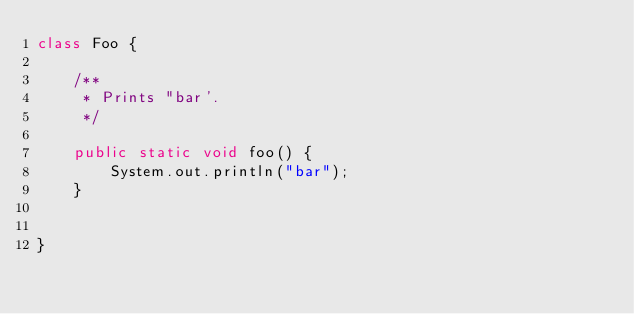Convert code to text. <code><loc_0><loc_0><loc_500><loc_500><_Java_>class Foo {

    /**
     * Prints "bar'.
     */

    public static void foo() {
        System.out.println("bar");
    }


}

</code> 